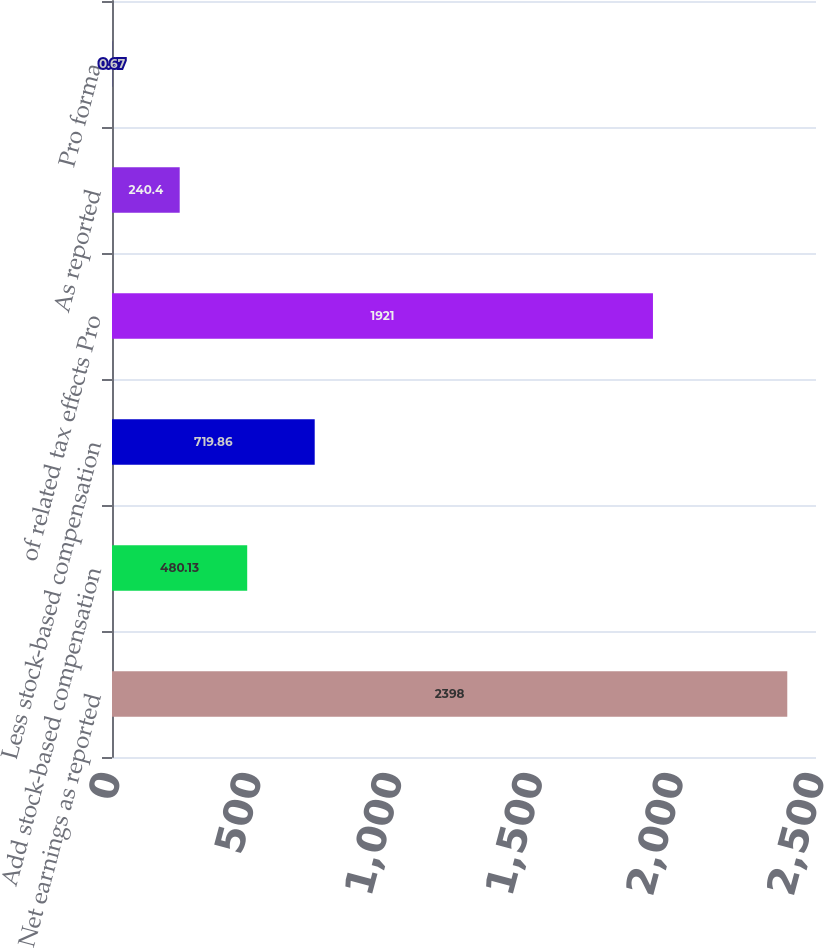<chart> <loc_0><loc_0><loc_500><loc_500><bar_chart><fcel>Net earnings as reported<fcel>Add stock-based compensation<fcel>Less stock-based compensation<fcel>of related tax effects Pro<fcel>As reported<fcel>Pro forma<nl><fcel>2398<fcel>480.13<fcel>719.86<fcel>1921<fcel>240.4<fcel>0.67<nl></chart> 